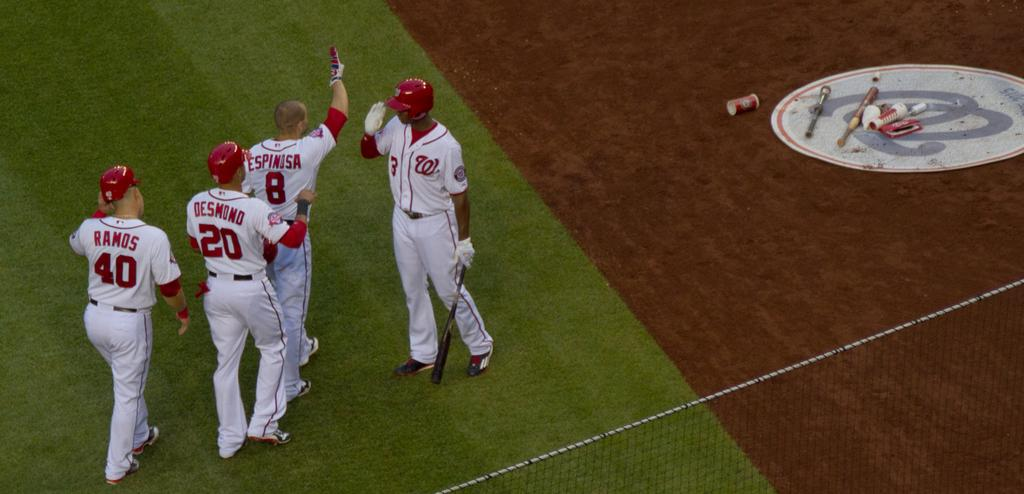<image>
Share a concise interpretation of the image provided. Ball players named Desmond and Ramos wear the 20 and 40 uniforms respectively. 